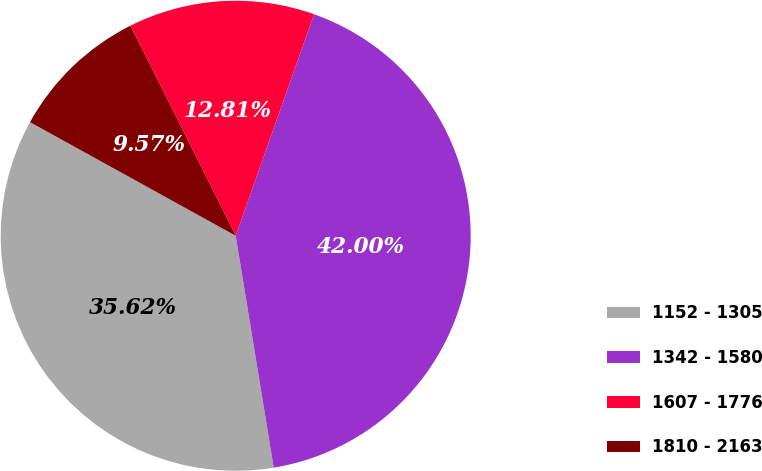<chart> <loc_0><loc_0><loc_500><loc_500><pie_chart><fcel>1152 - 1305<fcel>1342 - 1580<fcel>1607 - 1776<fcel>1810 - 2163<nl><fcel>35.62%<fcel>42.0%<fcel>12.81%<fcel>9.57%<nl></chart> 